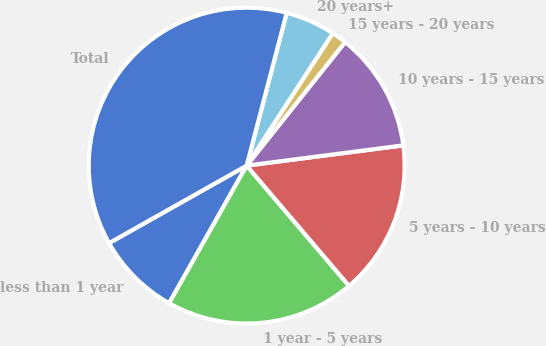<chart> <loc_0><loc_0><loc_500><loc_500><pie_chart><fcel>less than 1 year<fcel>1 year - 5 years<fcel>5 years - 10 years<fcel>10 years - 15 years<fcel>15 years - 20 years<fcel>20 years+<fcel>Total<nl><fcel>8.67%<fcel>19.39%<fcel>15.82%<fcel>12.25%<fcel>1.53%<fcel>5.1%<fcel>37.24%<nl></chart> 